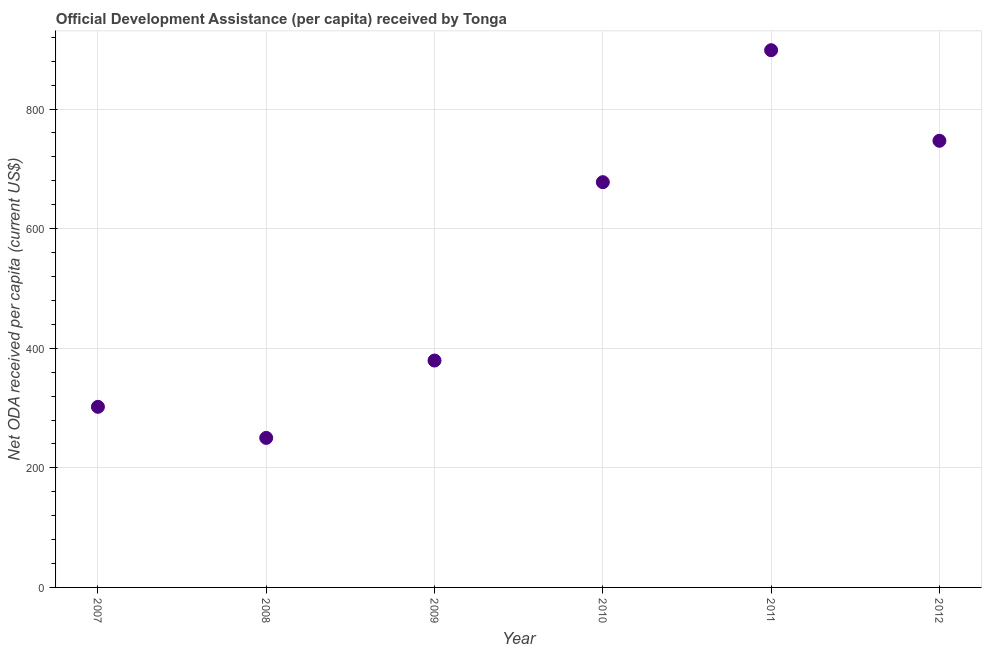What is the net oda received per capita in 2011?
Your answer should be very brief. 898.44. Across all years, what is the maximum net oda received per capita?
Keep it short and to the point. 898.44. Across all years, what is the minimum net oda received per capita?
Offer a terse response. 250.06. What is the sum of the net oda received per capita?
Provide a short and direct response. 3254.71. What is the difference between the net oda received per capita in 2010 and 2012?
Provide a short and direct response. -69.23. What is the average net oda received per capita per year?
Your answer should be compact. 542.45. What is the median net oda received per capita?
Your answer should be compact. 528.59. In how many years, is the net oda received per capita greater than 120 US$?
Offer a very short reply. 6. Do a majority of the years between 2012 and 2008 (inclusive) have net oda received per capita greater than 640 US$?
Your response must be concise. Yes. What is the ratio of the net oda received per capita in 2007 to that in 2012?
Your answer should be compact. 0.4. Is the net oda received per capita in 2008 less than that in 2012?
Keep it short and to the point. Yes. Is the difference between the net oda received per capita in 2007 and 2008 greater than the difference between any two years?
Your answer should be compact. No. What is the difference between the highest and the second highest net oda received per capita?
Keep it short and to the point. 151.46. Is the sum of the net oda received per capita in 2008 and 2009 greater than the maximum net oda received per capita across all years?
Give a very brief answer. No. What is the difference between the highest and the lowest net oda received per capita?
Offer a very short reply. 648.38. How many years are there in the graph?
Keep it short and to the point. 6. Are the values on the major ticks of Y-axis written in scientific E-notation?
Your response must be concise. No. Does the graph contain any zero values?
Give a very brief answer. No. What is the title of the graph?
Provide a short and direct response. Official Development Assistance (per capita) received by Tonga. What is the label or title of the Y-axis?
Ensure brevity in your answer.  Net ODA received per capita (current US$). What is the Net ODA received per capita (current US$) in 2007?
Ensure brevity in your answer.  302.05. What is the Net ODA received per capita (current US$) in 2008?
Provide a short and direct response. 250.06. What is the Net ODA received per capita (current US$) in 2009?
Keep it short and to the point. 379.44. What is the Net ODA received per capita (current US$) in 2010?
Provide a short and direct response. 677.75. What is the Net ODA received per capita (current US$) in 2011?
Make the answer very short. 898.44. What is the Net ODA received per capita (current US$) in 2012?
Your response must be concise. 746.98. What is the difference between the Net ODA received per capita (current US$) in 2007 and 2008?
Your answer should be compact. 51.99. What is the difference between the Net ODA received per capita (current US$) in 2007 and 2009?
Make the answer very short. -77.39. What is the difference between the Net ODA received per capita (current US$) in 2007 and 2010?
Your answer should be compact. -375.7. What is the difference between the Net ODA received per capita (current US$) in 2007 and 2011?
Keep it short and to the point. -596.39. What is the difference between the Net ODA received per capita (current US$) in 2007 and 2012?
Your answer should be compact. -444.93. What is the difference between the Net ODA received per capita (current US$) in 2008 and 2009?
Make the answer very short. -129.38. What is the difference between the Net ODA received per capita (current US$) in 2008 and 2010?
Your answer should be compact. -427.69. What is the difference between the Net ODA received per capita (current US$) in 2008 and 2011?
Give a very brief answer. -648.38. What is the difference between the Net ODA received per capita (current US$) in 2008 and 2012?
Your response must be concise. -496.92. What is the difference between the Net ODA received per capita (current US$) in 2009 and 2010?
Offer a very short reply. -298.31. What is the difference between the Net ODA received per capita (current US$) in 2009 and 2011?
Your answer should be compact. -519. What is the difference between the Net ODA received per capita (current US$) in 2009 and 2012?
Your answer should be compact. -367.54. What is the difference between the Net ODA received per capita (current US$) in 2010 and 2011?
Make the answer very short. -220.69. What is the difference between the Net ODA received per capita (current US$) in 2010 and 2012?
Keep it short and to the point. -69.23. What is the difference between the Net ODA received per capita (current US$) in 2011 and 2012?
Offer a terse response. 151.46. What is the ratio of the Net ODA received per capita (current US$) in 2007 to that in 2008?
Your answer should be compact. 1.21. What is the ratio of the Net ODA received per capita (current US$) in 2007 to that in 2009?
Provide a succinct answer. 0.8. What is the ratio of the Net ODA received per capita (current US$) in 2007 to that in 2010?
Your answer should be very brief. 0.45. What is the ratio of the Net ODA received per capita (current US$) in 2007 to that in 2011?
Give a very brief answer. 0.34. What is the ratio of the Net ODA received per capita (current US$) in 2007 to that in 2012?
Offer a terse response. 0.4. What is the ratio of the Net ODA received per capita (current US$) in 2008 to that in 2009?
Offer a very short reply. 0.66. What is the ratio of the Net ODA received per capita (current US$) in 2008 to that in 2010?
Ensure brevity in your answer.  0.37. What is the ratio of the Net ODA received per capita (current US$) in 2008 to that in 2011?
Your answer should be very brief. 0.28. What is the ratio of the Net ODA received per capita (current US$) in 2008 to that in 2012?
Keep it short and to the point. 0.34. What is the ratio of the Net ODA received per capita (current US$) in 2009 to that in 2010?
Offer a terse response. 0.56. What is the ratio of the Net ODA received per capita (current US$) in 2009 to that in 2011?
Offer a very short reply. 0.42. What is the ratio of the Net ODA received per capita (current US$) in 2009 to that in 2012?
Your response must be concise. 0.51. What is the ratio of the Net ODA received per capita (current US$) in 2010 to that in 2011?
Ensure brevity in your answer.  0.75. What is the ratio of the Net ODA received per capita (current US$) in 2010 to that in 2012?
Provide a succinct answer. 0.91. What is the ratio of the Net ODA received per capita (current US$) in 2011 to that in 2012?
Provide a succinct answer. 1.2. 